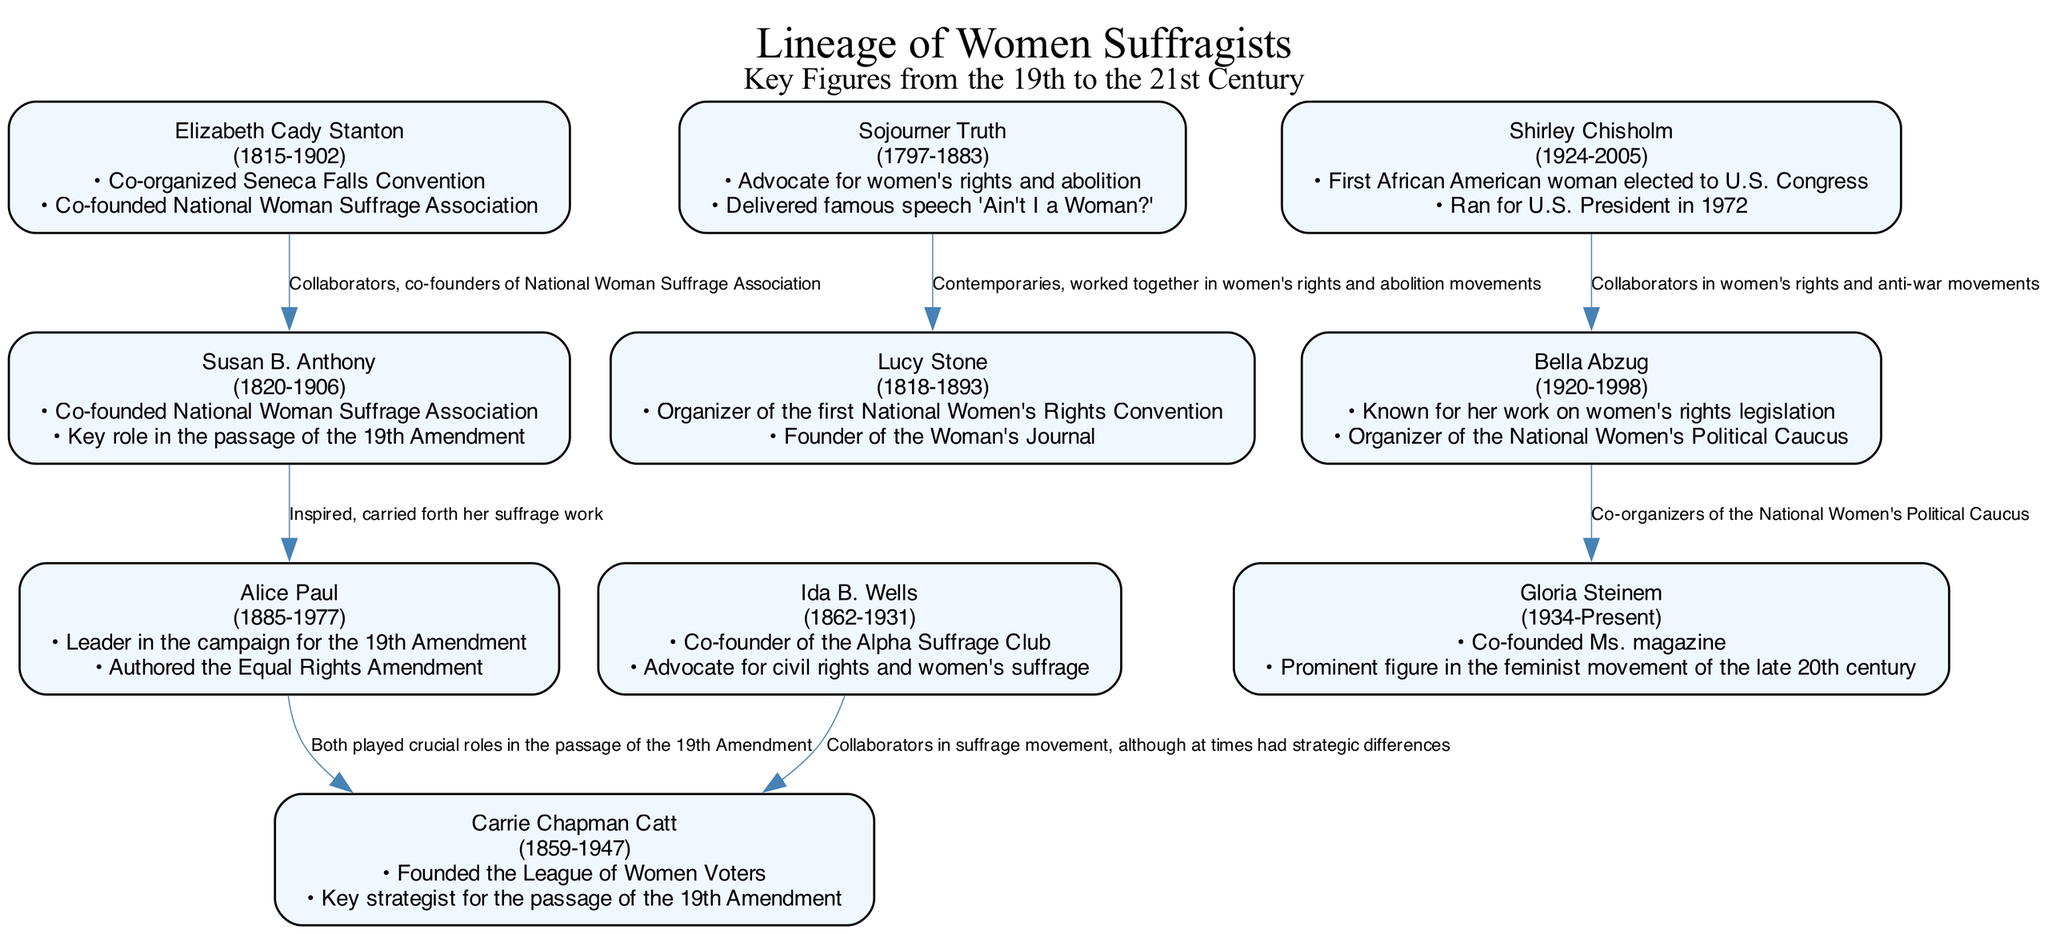What is the birth year of Elizabeth Cady Stanton? The diagram shows Elizabeth Cady Stanton's birth year at the top of her node, which is marked as 1815.
Answer: 1815 Who co-founded the National Woman Suffrage Association with Susan B. Anthony? Looking at the connections from Susan B. Anthony, one of the relationships indicates she co-founded the National Woman Suffrage Association with Elizabeth Cady Stanton.
Answer: Elizabeth Cady Stanton How many nodes are represented in the diagram? By visually counting the distinct figures presented in the diagram, there are a total of 10 nodes included for different suffragists.
Answer: 10 Who delivered the famous speech "Ain't I a Woman?" The node for Sojourner Truth lists her contributions, and one specifically notes that she delivered the famous speech "Ain't I a Woman?"
Answer: Sojourner Truth What relationship existed between Shirley Chisholm and Bella Abzug? The diagram states that Shirley Chisholm and Bella Abzug are collaborators in women's rights and anti-war movements, which is indicated in the connection between their nodes.
Answer: Collaborators in women's rights and anti-war movements Which suffragist is known for founding the League of Women Voters? Referring to the contribution listed under Carrie Chapman Catt’s node, it indicates she founded the League of Women Voters.
Answer: Carrie Chapman Catt What was one key role of Alice Paul? Alice Paul's contributions in the diagram highlight that she was a leader in the campaign for the 19th Amendment, showing her significant role in this movement.
Answer: Leader in the campaign for the 19th Amendment What is the birth year of the first African American woman elected to U.S. Congress? The diagram states that Shirley Chisholm, the first African American woman elected to U.S. Congress, was born in 1924, as indicated in her node.
Answer: 1924 Who is the prominent figure in the feminist movement of the late 20th century, according to the diagram? The diagram shows that Gloria Steinem is recognized as a prominent figure in the feminist movement of the late 20th century, based on the contributions listed in her node.
Answer: Gloria Steinem 